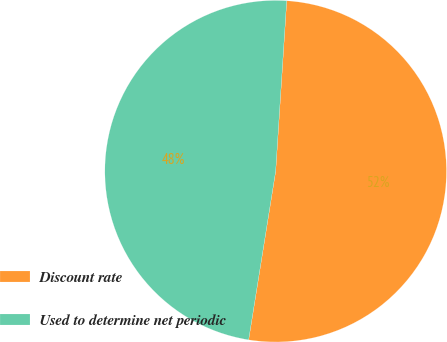<chart> <loc_0><loc_0><loc_500><loc_500><pie_chart><fcel>Discount rate<fcel>Used to determine net periodic<nl><fcel>51.5%<fcel>48.5%<nl></chart> 